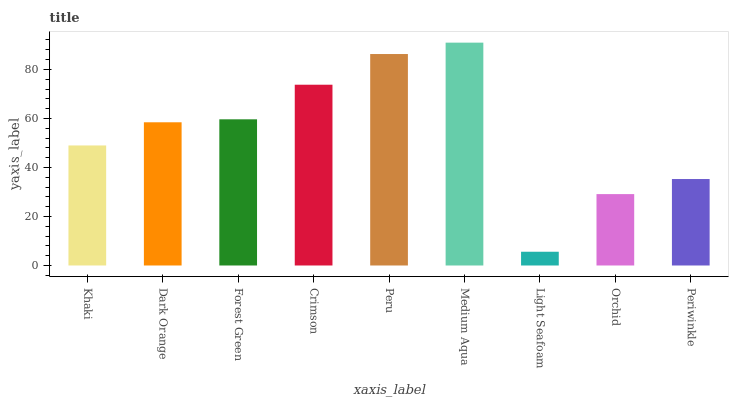Is Light Seafoam the minimum?
Answer yes or no. Yes. Is Medium Aqua the maximum?
Answer yes or no. Yes. Is Dark Orange the minimum?
Answer yes or no. No. Is Dark Orange the maximum?
Answer yes or no. No. Is Dark Orange greater than Khaki?
Answer yes or no. Yes. Is Khaki less than Dark Orange?
Answer yes or no. Yes. Is Khaki greater than Dark Orange?
Answer yes or no. No. Is Dark Orange less than Khaki?
Answer yes or no. No. Is Dark Orange the high median?
Answer yes or no. Yes. Is Dark Orange the low median?
Answer yes or no. Yes. Is Orchid the high median?
Answer yes or no. No. Is Orchid the low median?
Answer yes or no. No. 